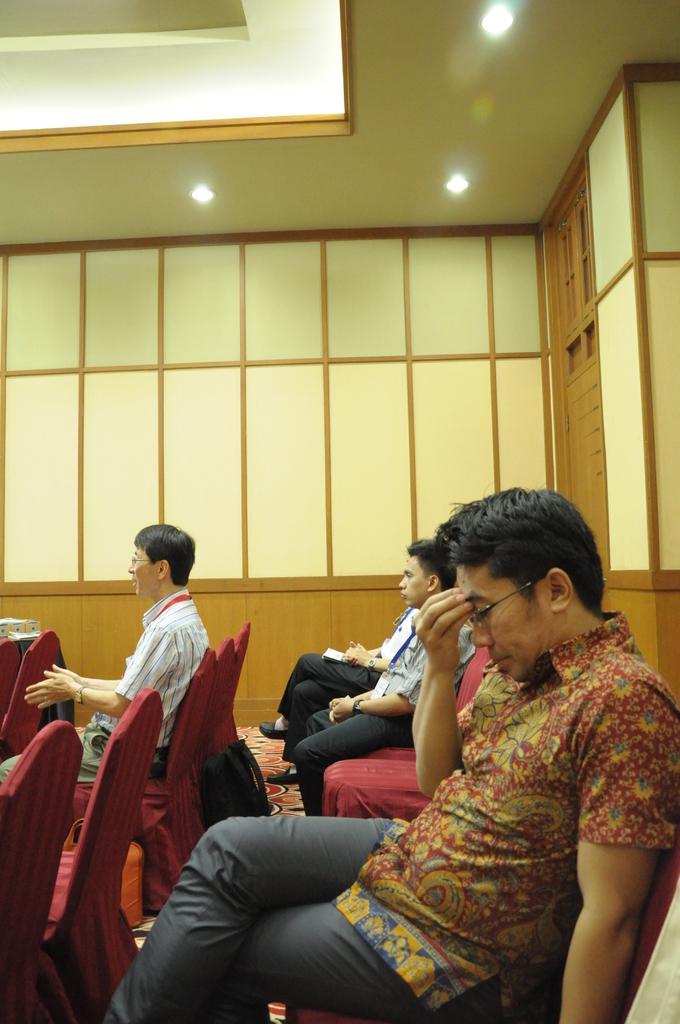Could you give a brief overview of what you see in this image? In this image we can see the people sitting on the chairs. Beside then we can see the wood wall with glasses and at the top we can see the ceiling with lights. 